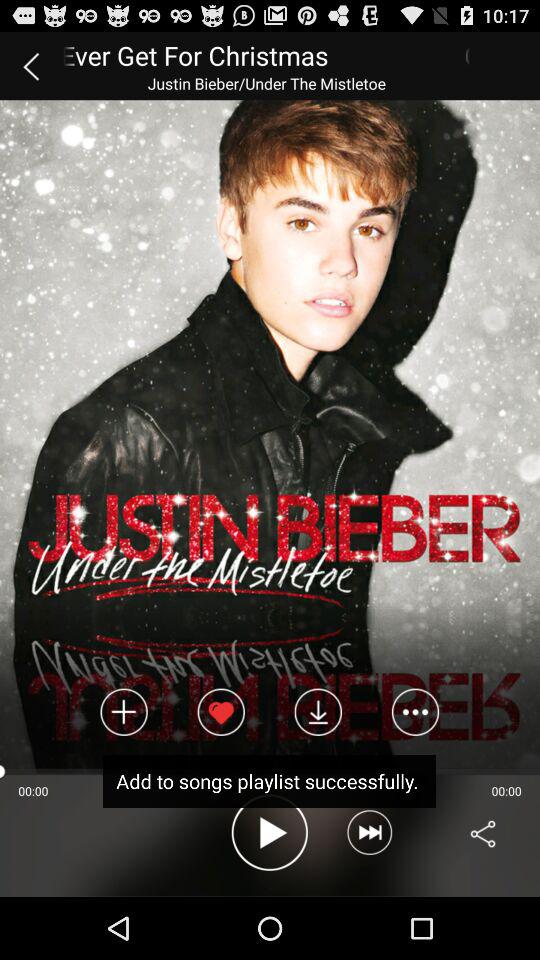What is the singer's name? The singer's name is Justin Bieber. 